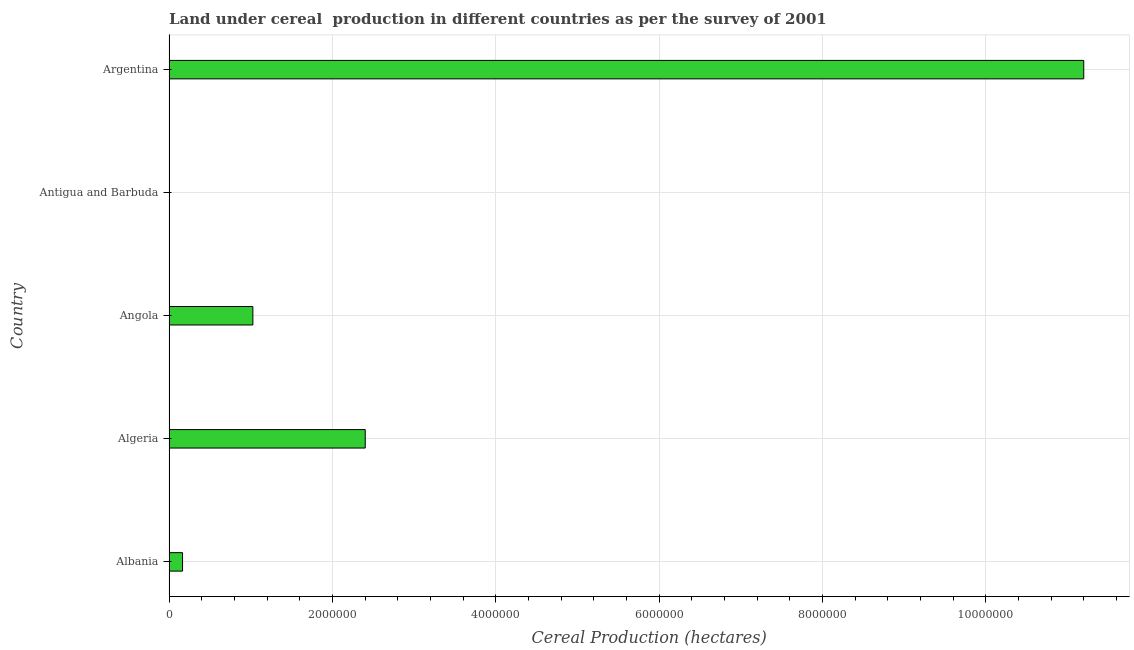Does the graph contain grids?
Your answer should be very brief. Yes. What is the title of the graph?
Your answer should be compact. Land under cereal  production in different countries as per the survey of 2001. What is the label or title of the X-axis?
Ensure brevity in your answer.  Cereal Production (hectares). What is the label or title of the Y-axis?
Provide a short and direct response. Country. What is the land under cereal production in Albania?
Make the answer very short. 1.66e+05. Across all countries, what is the maximum land under cereal production?
Offer a terse response. 1.12e+07. Across all countries, what is the minimum land under cereal production?
Your response must be concise. 31. In which country was the land under cereal production maximum?
Offer a very short reply. Argentina. In which country was the land under cereal production minimum?
Your response must be concise. Antigua and Barbuda. What is the sum of the land under cereal production?
Keep it short and to the point. 1.48e+07. What is the difference between the land under cereal production in Antigua and Barbuda and Argentina?
Offer a very short reply. -1.12e+07. What is the average land under cereal production per country?
Offer a very short reply. 2.96e+06. What is the median land under cereal production?
Offer a terse response. 1.03e+06. In how many countries, is the land under cereal production greater than 800000 hectares?
Make the answer very short. 3. What is the ratio of the land under cereal production in Antigua and Barbuda to that in Argentina?
Your response must be concise. 0. Is the difference between the land under cereal production in Algeria and Antigua and Barbuda greater than the difference between any two countries?
Make the answer very short. No. What is the difference between the highest and the second highest land under cereal production?
Your answer should be very brief. 8.80e+06. Is the sum of the land under cereal production in Algeria and Angola greater than the maximum land under cereal production across all countries?
Ensure brevity in your answer.  No. What is the difference between the highest and the lowest land under cereal production?
Offer a terse response. 1.12e+07. How many bars are there?
Provide a short and direct response. 5. What is the difference between two consecutive major ticks on the X-axis?
Offer a very short reply. 2.00e+06. Are the values on the major ticks of X-axis written in scientific E-notation?
Ensure brevity in your answer.  No. What is the Cereal Production (hectares) in Albania?
Your answer should be compact. 1.66e+05. What is the Cereal Production (hectares) in Algeria?
Your answer should be compact. 2.40e+06. What is the Cereal Production (hectares) of Angola?
Offer a very short reply. 1.03e+06. What is the Cereal Production (hectares) of Antigua and Barbuda?
Offer a very short reply. 31. What is the Cereal Production (hectares) of Argentina?
Provide a short and direct response. 1.12e+07. What is the difference between the Cereal Production (hectares) in Albania and Algeria?
Provide a short and direct response. -2.24e+06. What is the difference between the Cereal Production (hectares) in Albania and Angola?
Your answer should be compact. -8.61e+05. What is the difference between the Cereal Production (hectares) in Albania and Antigua and Barbuda?
Your response must be concise. 1.66e+05. What is the difference between the Cereal Production (hectares) in Albania and Argentina?
Provide a succinct answer. -1.10e+07. What is the difference between the Cereal Production (hectares) in Algeria and Angola?
Offer a very short reply. 1.38e+06. What is the difference between the Cereal Production (hectares) in Algeria and Antigua and Barbuda?
Offer a terse response. 2.40e+06. What is the difference between the Cereal Production (hectares) in Algeria and Argentina?
Your answer should be very brief. -8.80e+06. What is the difference between the Cereal Production (hectares) in Angola and Antigua and Barbuda?
Your response must be concise. 1.03e+06. What is the difference between the Cereal Production (hectares) in Angola and Argentina?
Your response must be concise. -1.02e+07. What is the difference between the Cereal Production (hectares) in Antigua and Barbuda and Argentina?
Your response must be concise. -1.12e+07. What is the ratio of the Cereal Production (hectares) in Albania to that in Algeria?
Your answer should be compact. 0.07. What is the ratio of the Cereal Production (hectares) in Albania to that in Angola?
Provide a short and direct response. 0.16. What is the ratio of the Cereal Production (hectares) in Albania to that in Antigua and Barbuda?
Your answer should be compact. 5348.39. What is the ratio of the Cereal Production (hectares) in Albania to that in Argentina?
Offer a terse response. 0.01. What is the ratio of the Cereal Production (hectares) in Algeria to that in Angola?
Provide a succinct answer. 2.34. What is the ratio of the Cereal Production (hectares) in Algeria to that in Antigua and Barbuda?
Your answer should be very brief. 7.75e+04. What is the ratio of the Cereal Production (hectares) in Algeria to that in Argentina?
Provide a succinct answer. 0.21. What is the ratio of the Cereal Production (hectares) in Angola to that in Antigua and Barbuda?
Ensure brevity in your answer.  3.31e+04. What is the ratio of the Cereal Production (hectares) in Angola to that in Argentina?
Provide a short and direct response. 0.09. 